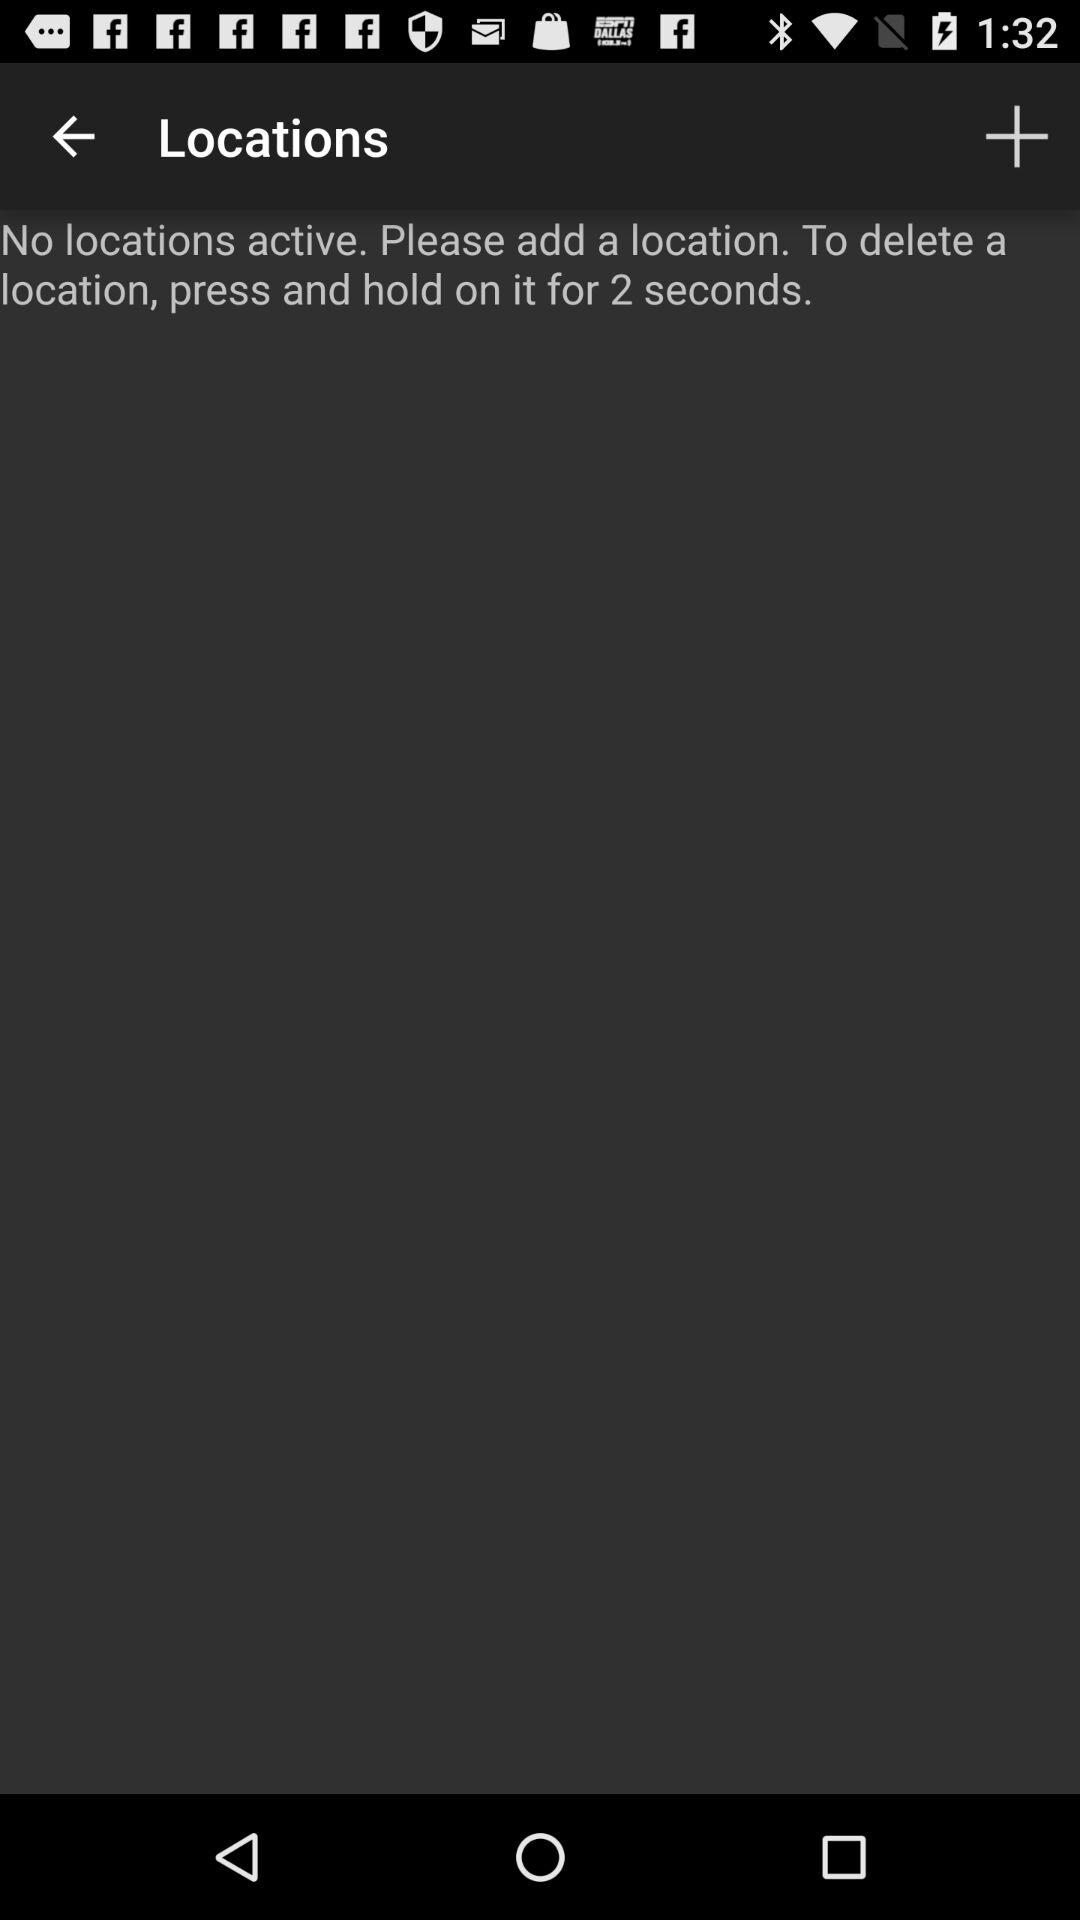How many locations are active?
Answer the question using a single word or phrase. 0 